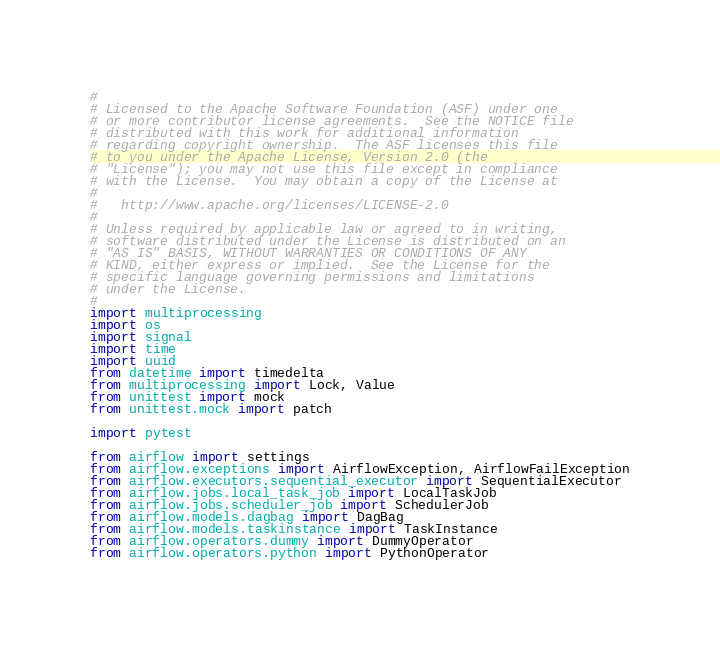Convert code to text. <code><loc_0><loc_0><loc_500><loc_500><_Python_>#
# Licensed to the Apache Software Foundation (ASF) under one
# or more contributor license agreements.  See the NOTICE file
# distributed with this work for additional information
# regarding copyright ownership.  The ASF licenses this file
# to you under the Apache License, Version 2.0 (the
# "License"); you may not use this file except in compliance
# with the License.  You may obtain a copy of the License at
#
#   http://www.apache.org/licenses/LICENSE-2.0
#
# Unless required by applicable law or agreed to in writing,
# software distributed under the License is distributed on an
# "AS IS" BASIS, WITHOUT WARRANTIES OR CONDITIONS OF ANY
# KIND, either express or implied.  See the License for the
# specific language governing permissions and limitations
# under the License.
#
import multiprocessing
import os
import signal
import time
import uuid
from datetime import timedelta
from multiprocessing import Lock, Value
from unittest import mock
from unittest.mock import patch

import pytest

from airflow import settings
from airflow.exceptions import AirflowException, AirflowFailException
from airflow.executors.sequential_executor import SequentialExecutor
from airflow.jobs.local_task_job import LocalTaskJob
from airflow.jobs.scheduler_job import SchedulerJob
from airflow.models.dagbag import DagBag
from airflow.models.taskinstance import TaskInstance
from airflow.operators.dummy import DummyOperator
from airflow.operators.python import PythonOperator</code> 